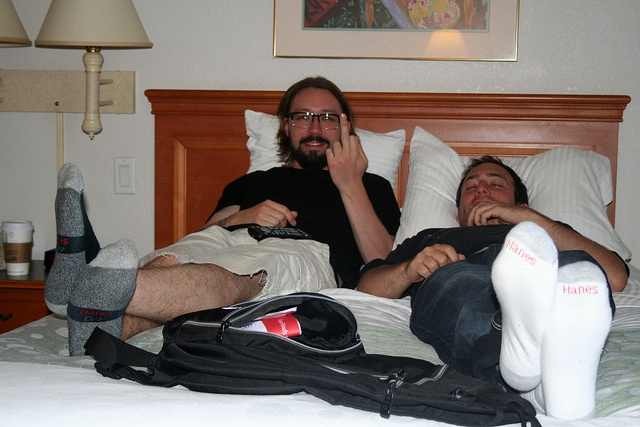Describe the objects in this image and their specific colors. I can see people in gray, black, and darkgray tones, people in gray, white, black, brown, and maroon tones, backpack in gray, black, and darkgray tones, bed in gray, maroon, and brown tones, and bed in gray, lightgray, darkgray, and black tones in this image. 